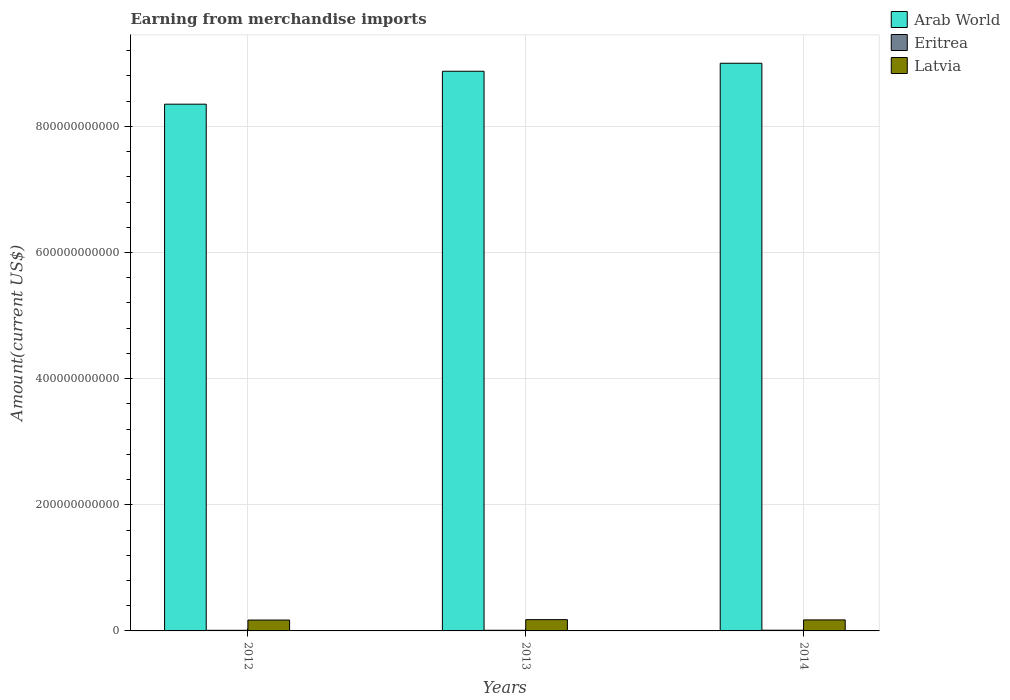How many different coloured bars are there?
Offer a terse response. 3. Are the number of bars per tick equal to the number of legend labels?
Your response must be concise. Yes. Are the number of bars on each tick of the X-axis equal?
Provide a short and direct response. Yes. How many bars are there on the 1st tick from the left?
Ensure brevity in your answer.  3. In how many cases, is the number of bars for a given year not equal to the number of legend labels?
Make the answer very short. 0. What is the amount earned from merchandise imports in Arab World in 2014?
Keep it short and to the point. 9.00e+11. Across all years, what is the maximum amount earned from merchandise imports in Latvia?
Your answer should be compact. 1.79e+1. Across all years, what is the minimum amount earned from merchandise imports in Arab World?
Provide a short and direct response. 8.35e+11. In which year was the amount earned from merchandise imports in Latvia minimum?
Make the answer very short. 2012. What is the total amount earned from merchandise imports in Latvia in the graph?
Your answer should be compact. 5.25e+1. What is the difference between the amount earned from merchandise imports in Arab World in 2012 and that in 2013?
Ensure brevity in your answer.  -5.22e+1. What is the difference between the amount earned from merchandise imports in Eritrea in 2014 and the amount earned from merchandise imports in Arab World in 2013?
Your answer should be compact. -8.86e+11. What is the average amount earned from merchandise imports in Latvia per year?
Offer a terse response. 1.75e+1. In the year 2013, what is the difference between the amount earned from merchandise imports in Arab World and amount earned from merchandise imports in Latvia?
Provide a short and direct response. 8.70e+11. In how many years, is the amount earned from merchandise imports in Arab World greater than 520000000000 US$?
Give a very brief answer. 3. What is the ratio of the amount earned from merchandise imports in Latvia in 2013 to that in 2014?
Provide a succinct answer. 1.02. Is the amount earned from merchandise imports in Latvia in 2012 less than that in 2014?
Offer a very short reply. Yes. Is the difference between the amount earned from merchandise imports in Arab World in 2012 and 2014 greater than the difference between the amount earned from merchandise imports in Latvia in 2012 and 2014?
Your response must be concise. No. What is the difference between the highest and the second highest amount earned from merchandise imports in Latvia?
Give a very brief answer. 4.15e+08. What is the difference between the highest and the lowest amount earned from merchandise imports in Eritrea?
Offer a terse response. 1.58e+08. In how many years, is the amount earned from merchandise imports in Eritrea greater than the average amount earned from merchandise imports in Eritrea taken over all years?
Your response must be concise. 1. What does the 1st bar from the left in 2012 represents?
Offer a very short reply. Arab World. What does the 2nd bar from the right in 2014 represents?
Provide a short and direct response. Eritrea. Is it the case that in every year, the sum of the amount earned from merchandise imports in Eritrea and amount earned from merchandise imports in Latvia is greater than the amount earned from merchandise imports in Arab World?
Your response must be concise. No. What is the difference between two consecutive major ticks on the Y-axis?
Your answer should be compact. 2.00e+11. How many legend labels are there?
Give a very brief answer. 3. What is the title of the graph?
Your response must be concise. Earning from merchandise imports. What is the label or title of the Y-axis?
Provide a short and direct response. Amount(current US$). What is the Amount(current US$) in Arab World in 2012?
Make the answer very short. 8.35e+11. What is the Amount(current US$) of Eritrea in 2012?
Ensure brevity in your answer.  9.70e+08. What is the Amount(current US$) in Latvia in 2012?
Ensure brevity in your answer.  1.72e+1. What is the Amount(current US$) of Arab World in 2013?
Your answer should be very brief. 8.87e+11. What is the Amount(current US$) in Eritrea in 2013?
Give a very brief answer. 1.03e+09. What is the Amount(current US$) of Latvia in 2013?
Offer a very short reply. 1.79e+1. What is the Amount(current US$) of Arab World in 2014?
Ensure brevity in your answer.  9.00e+11. What is the Amount(current US$) of Eritrea in 2014?
Make the answer very short. 1.13e+09. What is the Amount(current US$) in Latvia in 2014?
Ensure brevity in your answer.  1.74e+1. Across all years, what is the maximum Amount(current US$) of Arab World?
Provide a short and direct response. 9.00e+11. Across all years, what is the maximum Amount(current US$) of Eritrea?
Ensure brevity in your answer.  1.13e+09. Across all years, what is the maximum Amount(current US$) of Latvia?
Ensure brevity in your answer.  1.79e+1. Across all years, what is the minimum Amount(current US$) in Arab World?
Keep it short and to the point. 8.35e+11. Across all years, what is the minimum Amount(current US$) in Eritrea?
Offer a terse response. 9.70e+08. Across all years, what is the minimum Amount(current US$) of Latvia?
Make the answer very short. 1.72e+1. What is the total Amount(current US$) in Arab World in the graph?
Offer a very short reply. 2.62e+12. What is the total Amount(current US$) in Eritrea in the graph?
Give a very brief answer. 3.13e+09. What is the total Amount(current US$) in Latvia in the graph?
Ensure brevity in your answer.  5.25e+1. What is the difference between the Amount(current US$) in Arab World in 2012 and that in 2013?
Offer a very short reply. -5.22e+1. What is the difference between the Amount(current US$) of Eritrea in 2012 and that in 2013?
Your answer should be very brief. -6.00e+07. What is the difference between the Amount(current US$) in Latvia in 2012 and that in 2013?
Your response must be concise. -6.37e+08. What is the difference between the Amount(current US$) in Arab World in 2012 and that in 2014?
Offer a very short reply. -6.49e+1. What is the difference between the Amount(current US$) in Eritrea in 2012 and that in 2014?
Offer a terse response. -1.58e+08. What is the difference between the Amount(current US$) of Latvia in 2012 and that in 2014?
Provide a short and direct response. -2.22e+08. What is the difference between the Amount(current US$) of Arab World in 2013 and that in 2014?
Your response must be concise. -1.27e+1. What is the difference between the Amount(current US$) in Eritrea in 2013 and that in 2014?
Make the answer very short. -9.82e+07. What is the difference between the Amount(current US$) of Latvia in 2013 and that in 2014?
Offer a very short reply. 4.15e+08. What is the difference between the Amount(current US$) of Arab World in 2012 and the Amount(current US$) of Eritrea in 2013?
Your answer should be compact. 8.34e+11. What is the difference between the Amount(current US$) of Arab World in 2012 and the Amount(current US$) of Latvia in 2013?
Your answer should be compact. 8.17e+11. What is the difference between the Amount(current US$) in Eritrea in 2012 and the Amount(current US$) in Latvia in 2013?
Provide a succinct answer. -1.69e+1. What is the difference between the Amount(current US$) in Arab World in 2012 and the Amount(current US$) in Eritrea in 2014?
Offer a terse response. 8.34e+11. What is the difference between the Amount(current US$) in Arab World in 2012 and the Amount(current US$) in Latvia in 2014?
Ensure brevity in your answer.  8.18e+11. What is the difference between the Amount(current US$) of Eritrea in 2012 and the Amount(current US$) of Latvia in 2014?
Make the answer very short. -1.65e+1. What is the difference between the Amount(current US$) in Arab World in 2013 and the Amount(current US$) in Eritrea in 2014?
Your answer should be very brief. 8.86e+11. What is the difference between the Amount(current US$) of Arab World in 2013 and the Amount(current US$) of Latvia in 2014?
Make the answer very short. 8.70e+11. What is the difference between the Amount(current US$) in Eritrea in 2013 and the Amount(current US$) in Latvia in 2014?
Provide a short and direct response. -1.64e+1. What is the average Amount(current US$) of Arab World per year?
Provide a short and direct response. 8.74e+11. What is the average Amount(current US$) in Eritrea per year?
Offer a terse response. 1.04e+09. What is the average Amount(current US$) of Latvia per year?
Your response must be concise. 1.75e+1. In the year 2012, what is the difference between the Amount(current US$) of Arab World and Amount(current US$) of Eritrea?
Your response must be concise. 8.34e+11. In the year 2012, what is the difference between the Amount(current US$) of Arab World and Amount(current US$) of Latvia?
Your response must be concise. 8.18e+11. In the year 2012, what is the difference between the Amount(current US$) of Eritrea and Amount(current US$) of Latvia?
Offer a terse response. -1.63e+1. In the year 2013, what is the difference between the Amount(current US$) of Arab World and Amount(current US$) of Eritrea?
Offer a very short reply. 8.86e+11. In the year 2013, what is the difference between the Amount(current US$) of Arab World and Amount(current US$) of Latvia?
Offer a terse response. 8.70e+11. In the year 2013, what is the difference between the Amount(current US$) of Eritrea and Amount(current US$) of Latvia?
Provide a short and direct response. -1.68e+1. In the year 2014, what is the difference between the Amount(current US$) of Arab World and Amount(current US$) of Eritrea?
Provide a succinct answer. 8.99e+11. In the year 2014, what is the difference between the Amount(current US$) in Arab World and Amount(current US$) in Latvia?
Give a very brief answer. 8.83e+11. In the year 2014, what is the difference between the Amount(current US$) in Eritrea and Amount(current US$) in Latvia?
Your answer should be very brief. -1.63e+1. What is the ratio of the Amount(current US$) of Eritrea in 2012 to that in 2013?
Give a very brief answer. 0.94. What is the ratio of the Amount(current US$) in Arab World in 2012 to that in 2014?
Give a very brief answer. 0.93. What is the ratio of the Amount(current US$) in Eritrea in 2012 to that in 2014?
Your answer should be very brief. 0.86. What is the ratio of the Amount(current US$) in Latvia in 2012 to that in 2014?
Give a very brief answer. 0.99. What is the ratio of the Amount(current US$) in Arab World in 2013 to that in 2014?
Make the answer very short. 0.99. What is the ratio of the Amount(current US$) of Eritrea in 2013 to that in 2014?
Ensure brevity in your answer.  0.91. What is the ratio of the Amount(current US$) in Latvia in 2013 to that in 2014?
Offer a very short reply. 1.02. What is the difference between the highest and the second highest Amount(current US$) in Arab World?
Ensure brevity in your answer.  1.27e+1. What is the difference between the highest and the second highest Amount(current US$) of Eritrea?
Ensure brevity in your answer.  9.82e+07. What is the difference between the highest and the second highest Amount(current US$) of Latvia?
Provide a short and direct response. 4.15e+08. What is the difference between the highest and the lowest Amount(current US$) of Arab World?
Your answer should be compact. 6.49e+1. What is the difference between the highest and the lowest Amount(current US$) of Eritrea?
Offer a terse response. 1.58e+08. What is the difference between the highest and the lowest Amount(current US$) of Latvia?
Ensure brevity in your answer.  6.37e+08. 